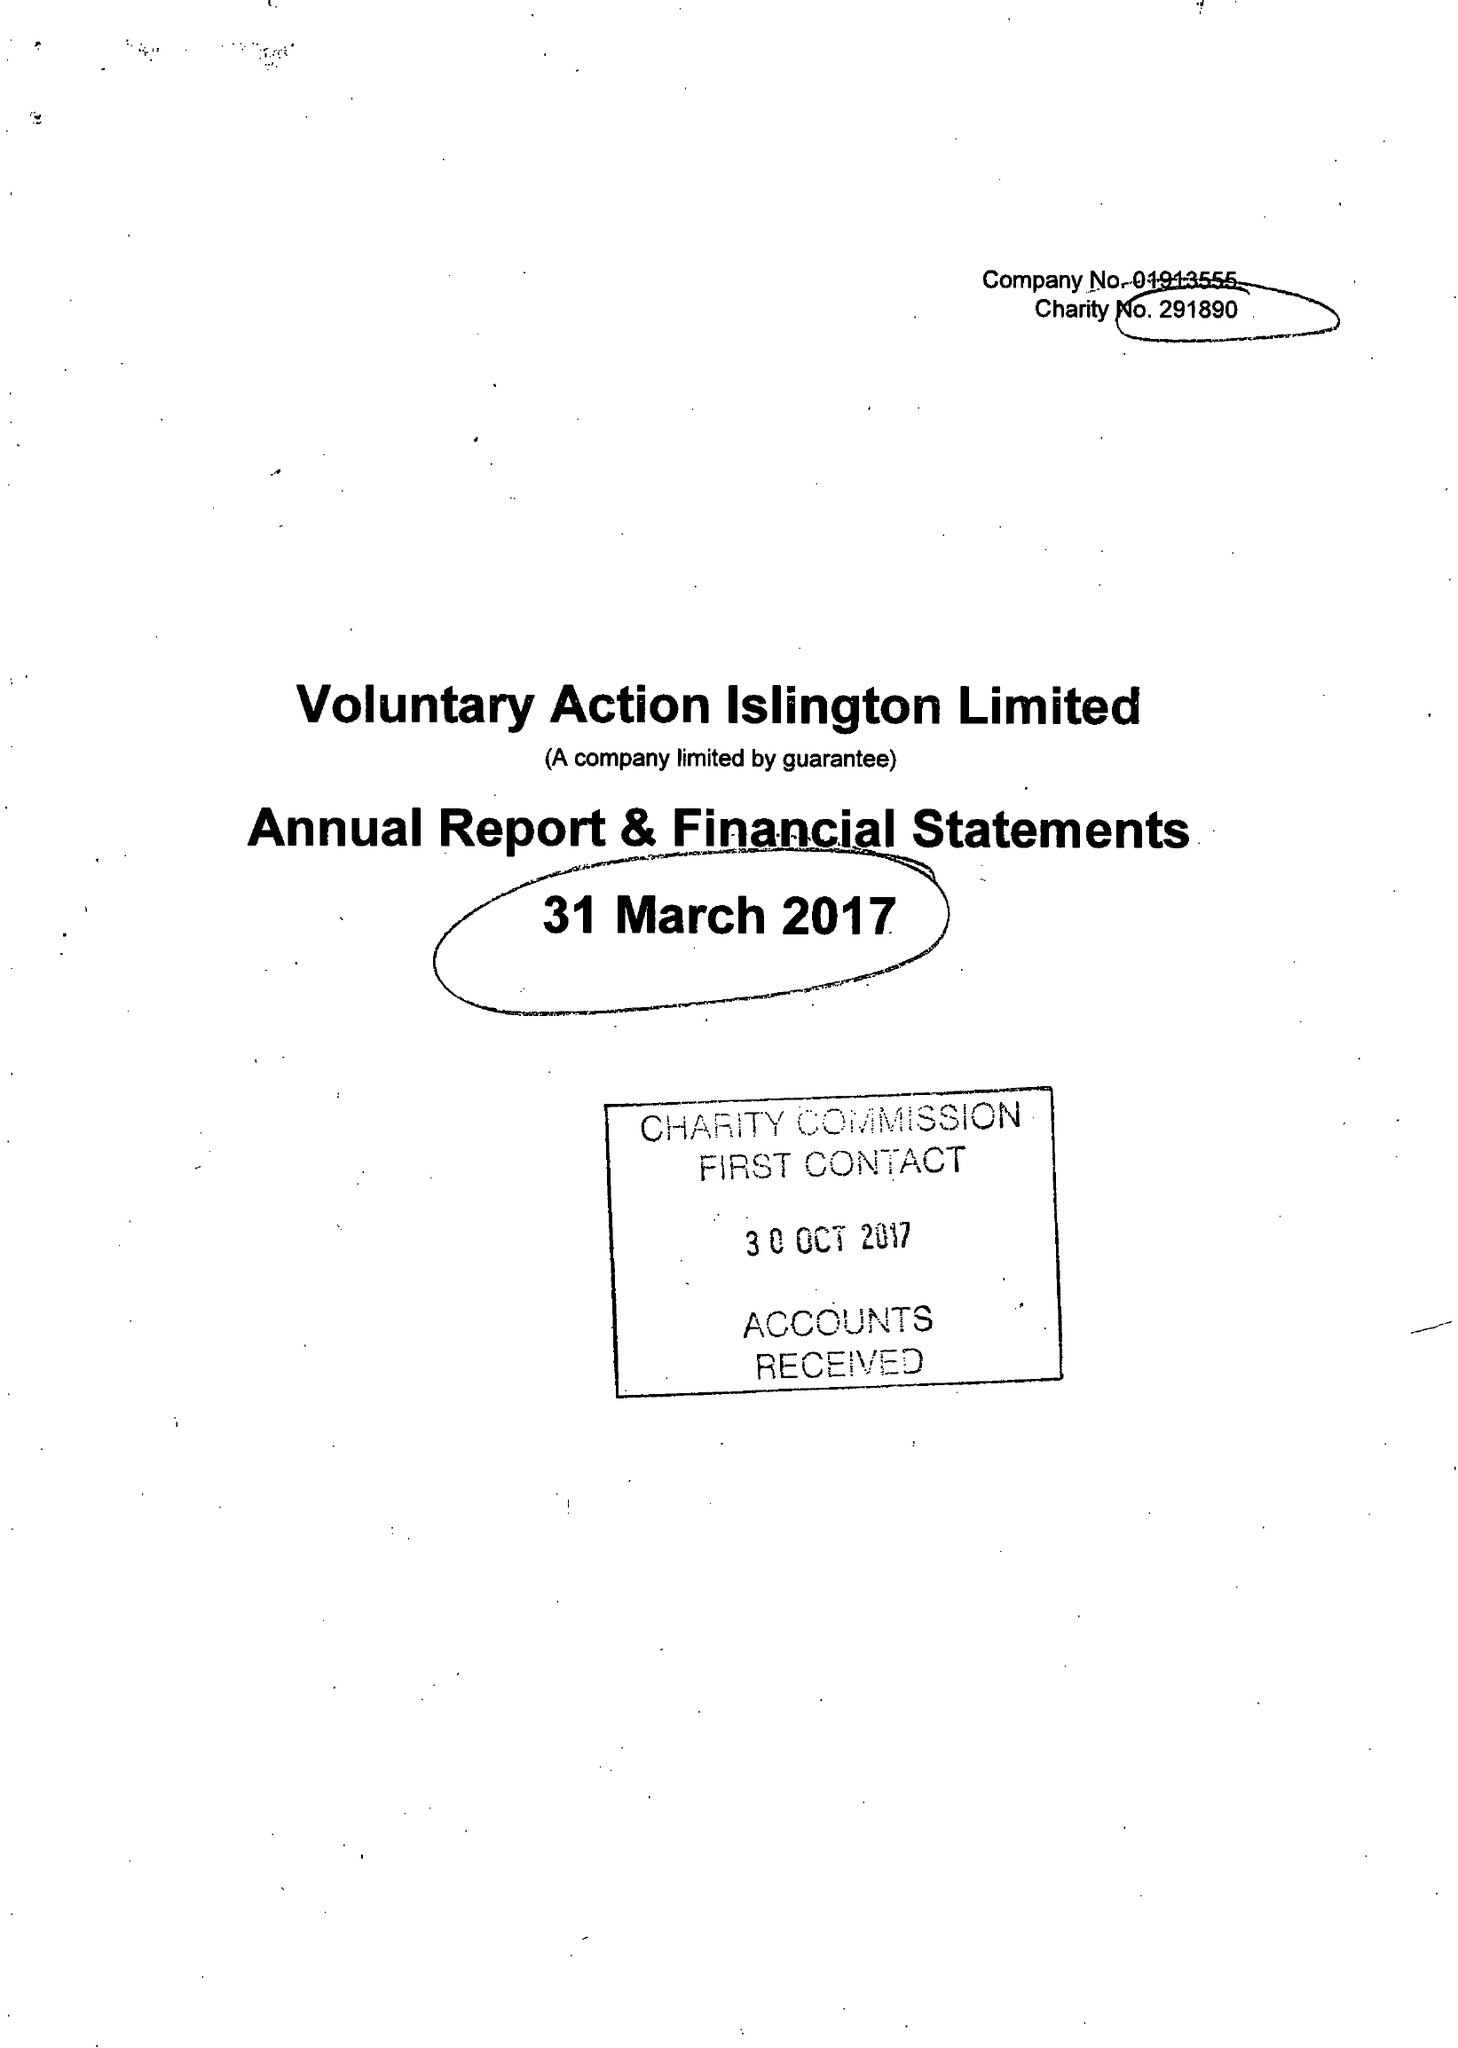What is the value for the spending_annually_in_british_pounds?
Answer the question using a single word or phrase. 444069.00 